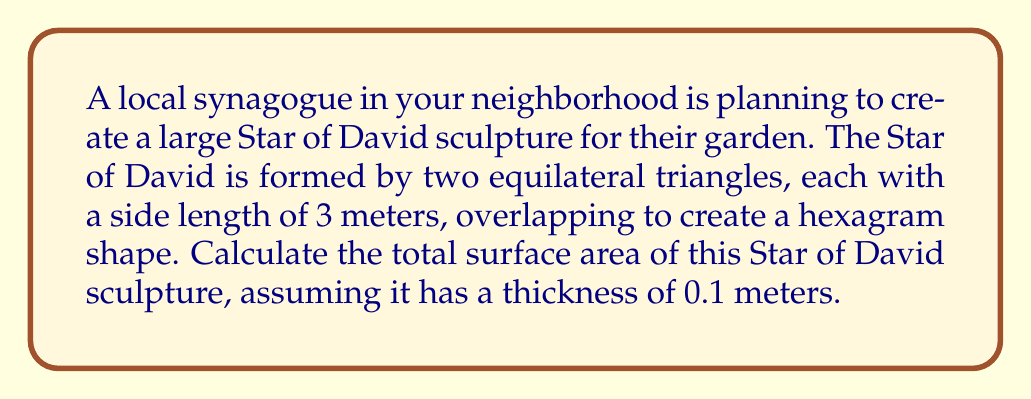Help me with this question. Let's approach this step-by-step:

1) First, we need to calculate the area of one equilateral triangle:
   The area of an equilateral triangle is given by the formula:
   $$ A = \frac{\sqrt{3}}{4} a^2 $$
   where $a$ is the side length.

   With $a = 3$ meters:
   $$ A = \frac{\sqrt{3}}{4} (3)^2 = \frac{9\sqrt{3}}{4} \approx 3.897 \text{ m}^2 $$

2) The Star of David consists of two such triangles, so the total flat surface area is:
   $$ 2 \cdot \frac{9\sqrt{3}}{4} = \frac{9\sqrt{3}}{2} \approx 7.794 \text{ m}^2 $$

3) Now, we need to account for the thickness. The sculpture has six edges, each 3 meters long and 0.1 meters thick. The area of each edge is:
   $$ 3 \text{ m} \cdot 0.1 \text{ m} = 0.3 \text{ m}^2 $$

4) Total edge area:
   $$ 6 \cdot 0.3 \text{ m}^2 = 1.8 \text{ m}^2 $$

5) The total surface area is the sum of both flat sides and all edges:
   $$ \text{Total Area} = 2 \cdot \frac{9\sqrt{3}}{2} + 1.8 = 9\sqrt{3} + 1.8 \approx 17.388 \text{ m}^2 $$

[asy]
unitsize(30);
pair A = (0,0), B = (1,0), C = (-0.5, 0.866), D = (0.5, 0.866);
draw(A--B--D--A--C--B, linewidth(1));
draw(C--D, linewidth(1));
label("3m", (A+B)/2, S);
[/asy]
Answer: $9\sqrt{3} + 1.8 \approx 17.388 \text{ m}^2$ 